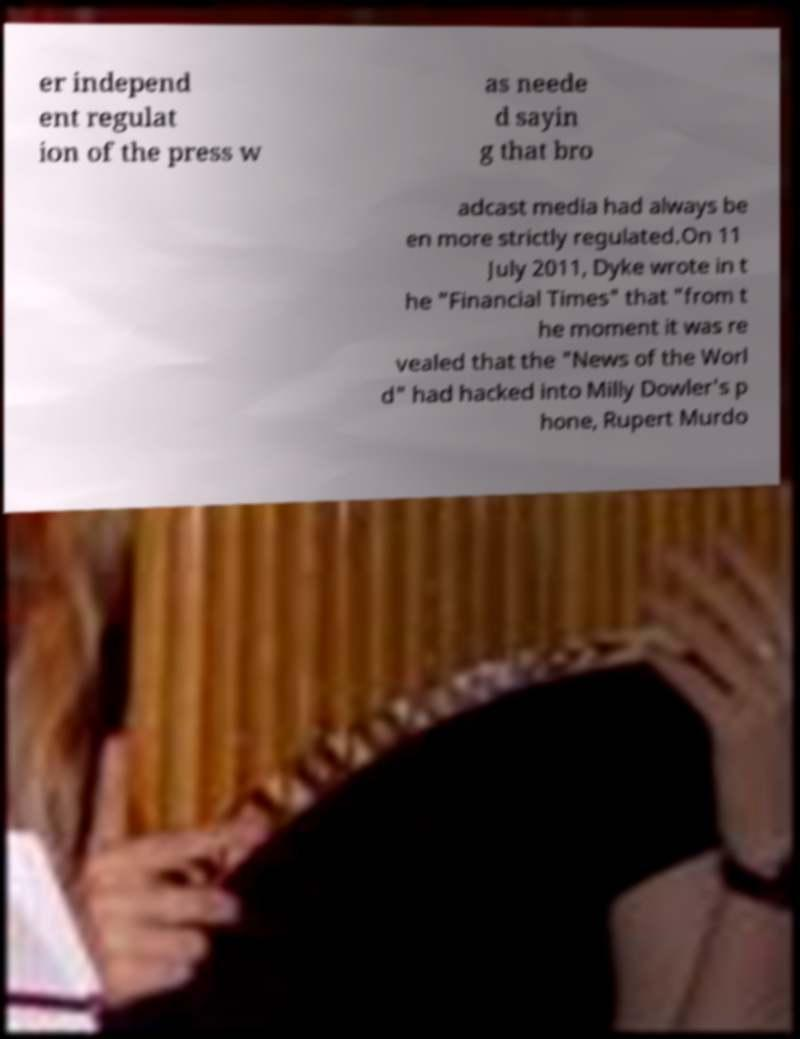Could you extract and type out the text from this image? er independ ent regulat ion of the press w as neede d sayin g that bro adcast media had always be en more strictly regulated.On 11 July 2011, Dyke wrote in t he "Financial Times" that "from t he moment it was re vealed that the "News of the Worl d" had hacked into Milly Dowler's p hone, Rupert Murdo 